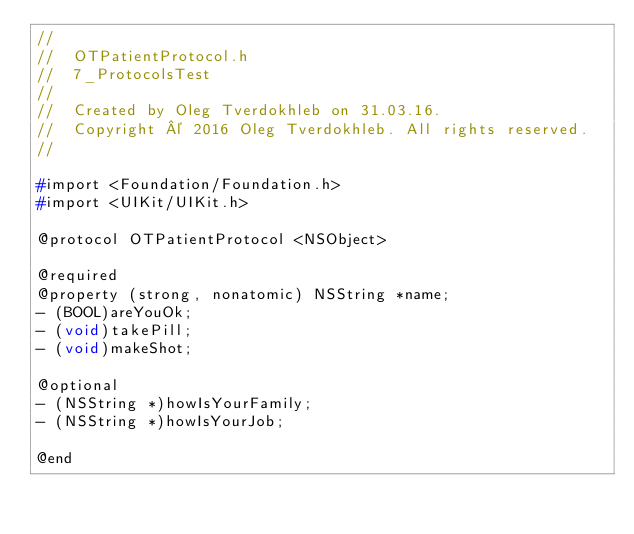Convert code to text. <code><loc_0><loc_0><loc_500><loc_500><_C_>//
//  OTPatientProtocol.h
//  7_ProtocolsTest
//
//  Created by Oleg Tverdokhleb on 31.03.16.
//  Copyright © 2016 Oleg Tverdokhleb. All rights reserved.
//

#import <Foundation/Foundation.h>
#import <UIKit/UIKit.h>

@protocol OTPatientProtocol <NSObject>

@required
@property (strong, nonatomic) NSString *name;
- (BOOL)areYouOk;
- (void)takePill;
- (void)makeShot;

@optional
- (NSString *)howIsYourFamily;
- (NSString *)howIsYourJob;

@end</code> 